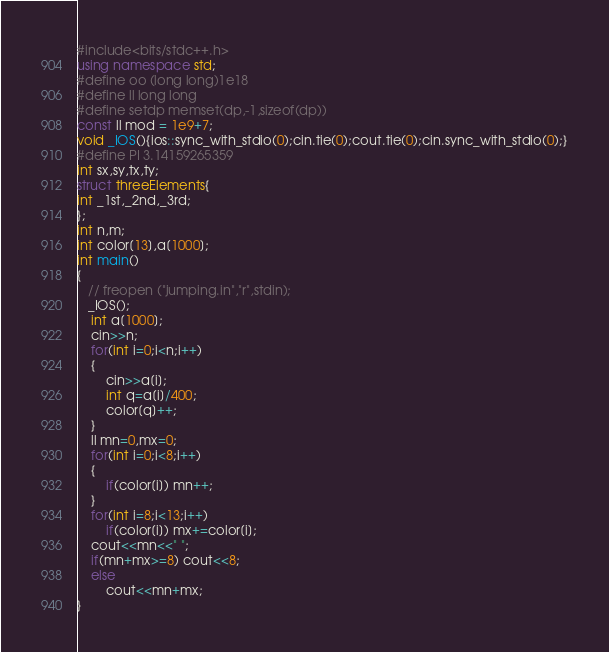Convert code to text. <code><loc_0><loc_0><loc_500><loc_500><_C++_>#include<bits/stdc++.h>
using namespace std;
#define oo (long long)1e18
#define ll long long
#define setdp memset(dp,-1,sizeof(dp))
const ll mod = 1e9+7;
void _IOS(){ios::sync_with_stdio(0);cin.tie(0);cout.tie(0);cin.sync_with_stdio(0);}
#define PI 3.14159265359
int sx,sy,tx,ty;
struct threeElements{
int _1st,_2nd,_3rd;
};
int n,m;
int color[13],a[1000];
int main()
{
   // freopen ("jumping.in","r",stdin);
   _IOS();
    int a[1000];
    cin>>n;
    for(int i=0;i<n;i++)
    {
        cin>>a[i];
        int q=a[i]/400;
        color[q]++;
    }
    ll mn=0,mx=0;
    for(int i=0;i<8;i++)
    {
        if(color[i]) mn++;
    }
    for(int i=8;i<13;i++)
        if(color[i]) mx+=color[i];
    cout<<mn<<" ";
    if(mn+mx>=8) cout<<8;
    else
        cout<<mn+mx;
}
</code> 